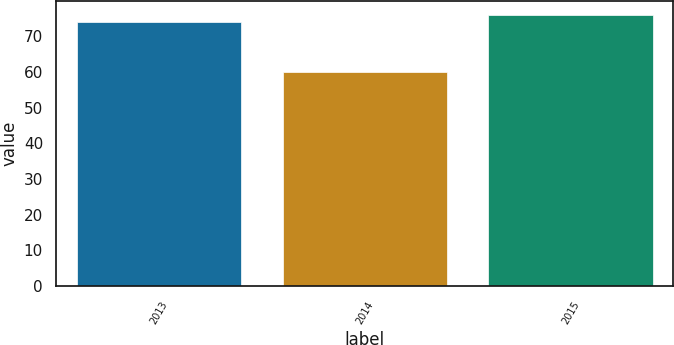Convert chart. <chart><loc_0><loc_0><loc_500><loc_500><bar_chart><fcel>2013<fcel>2014<fcel>2015<nl><fcel>74<fcel>60<fcel>76<nl></chart> 